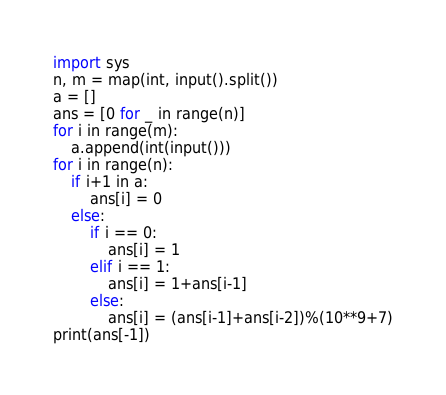<code> <loc_0><loc_0><loc_500><loc_500><_Python_>import sys
n, m = map(int, input().split())
a = []
ans = [0 for _ in range(n)]
for i in range(m):
    a.append(int(input()))
for i in range(n):
    if i+1 in a:
        ans[i] = 0
    else:
        if i == 0:
            ans[i] = 1
        elif i == 1:
            ans[i] = 1+ans[i-1]
        else:
            ans[i] = (ans[i-1]+ans[i-2])%(10**9+7)
print(ans[-1])
</code> 